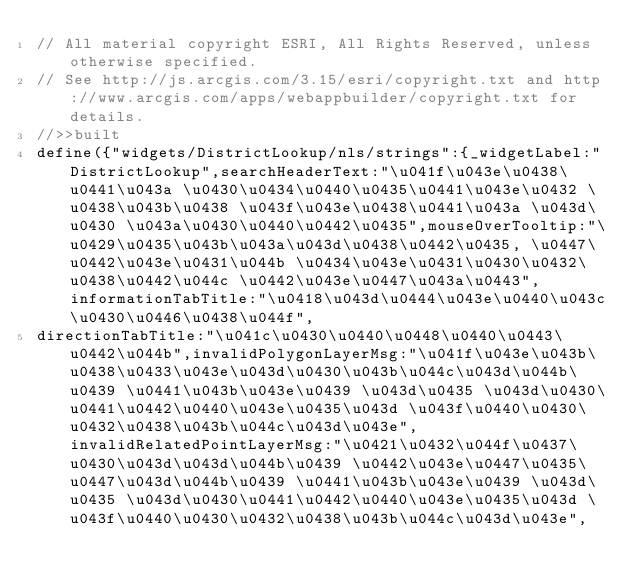Convert code to text. <code><loc_0><loc_0><loc_500><loc_500><_JavaScript_>// All material copyright ESRI, All Rights Reserved, unless otherwise specified.
// See http://js.arcgis.com/3.15/esri/copyright.txt and http://www.arcgis.com/apps/webappbuilder/copyright.txt for details.
//>>built
define({"widgets/DistrictLookup/nls/strings":{_widgetLabel:"DistrictLookup",searchHeaderText:"\u041f\u043e\u0438\u0441\u043a \u0430\u0434\u0440\u0435\u0441\u043e\u0432 \u0438\u043b\u0438 \u043f\u043e\u0438\u0441\u043a \u043d\u0430 \u043a\u0430\u0440\u0442\u0435",mouseOverTooltip:"\u0429\u0435\u043b\u043a\u043d\u0438\u0442\u0435, \u0447\u0442\u043e\u0431\u044b \u0434\u043e\u0431\u0430\u0432\u0438\u0442\u044c \u0442\u043e\u0447\u043a\u0443",informationTabTitle:"\u0418\u043d\u0444\u043e\u0440\u043c\u0430\u0446\u0438\u044f",
directionTabTitle:"\u041c\u0430\u0440\u0448\u0440\u0443\u0442\u044b",invalidPolygonLayerMsg:"\u041f\u043e\u043b\u0438\u0433\u043e\u043d\u0430\u043b\u044c\u043d\u044b\u0439 \u0441\u043b\u043e\u0439 \u043d\u0435 \u043d\u0430\u0441\u0442\u0440\u043e\u0435\u043d \u043f\u0440\u0430\u0432\u0438\u043b\u044c\u043d\u043e",invalidRelatedPointLayerMsg:"\u0421\u0432\u044f\u0437\u0430\u043d\u043d\u044b\u0439 \u0442\u043e\u0447\u0435\u0447\u043d\u044b\u0439 \u0441\u043b\u043e\u0439 \u043d\u0435 \u043d\u0430\u0441\u0442\u0440\u043e\u0435\u043d \u043f\u0440\u0430\u0432\u0438\u043b\u044c\u043d\u043e",</code> 